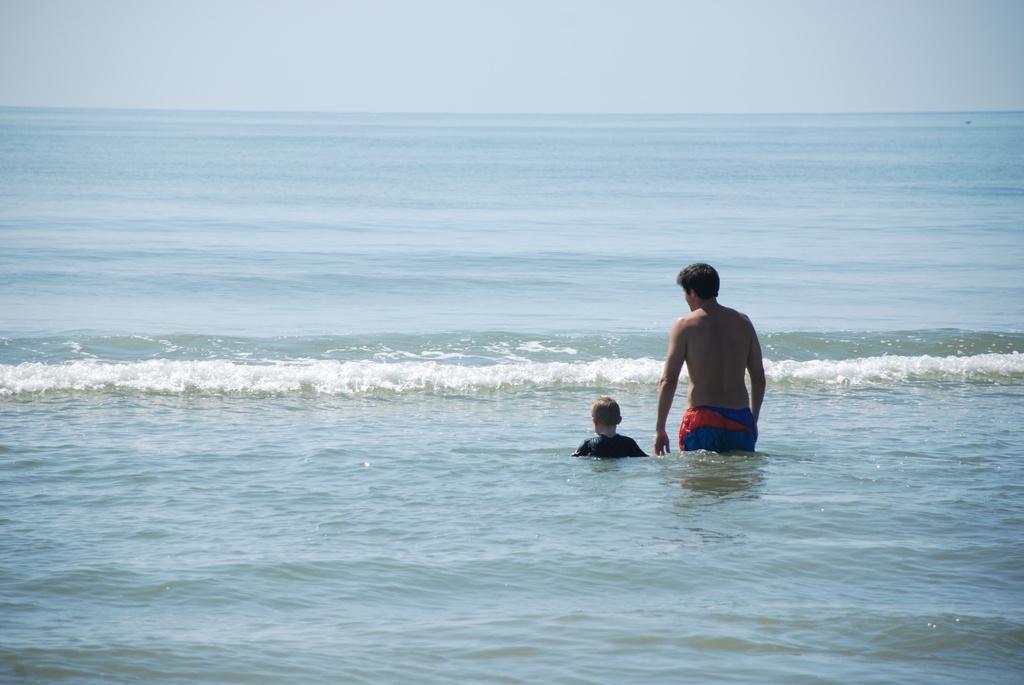In one or two sentences, can you explain what this image depicts? In this image at the bottom there is a beach and in the beach there is one man and one boy, at the top of the match there is sky. 